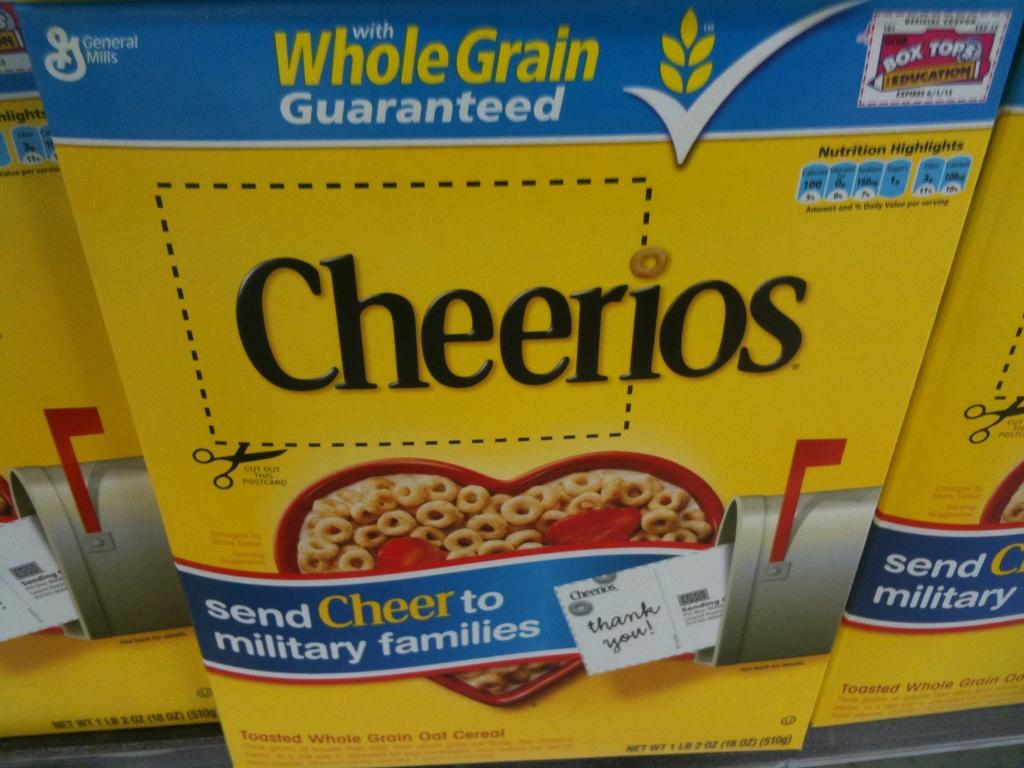Provide a one-sentence caption for the provided image. A box of Cheerios, whole grain guaranteed with box tops. 